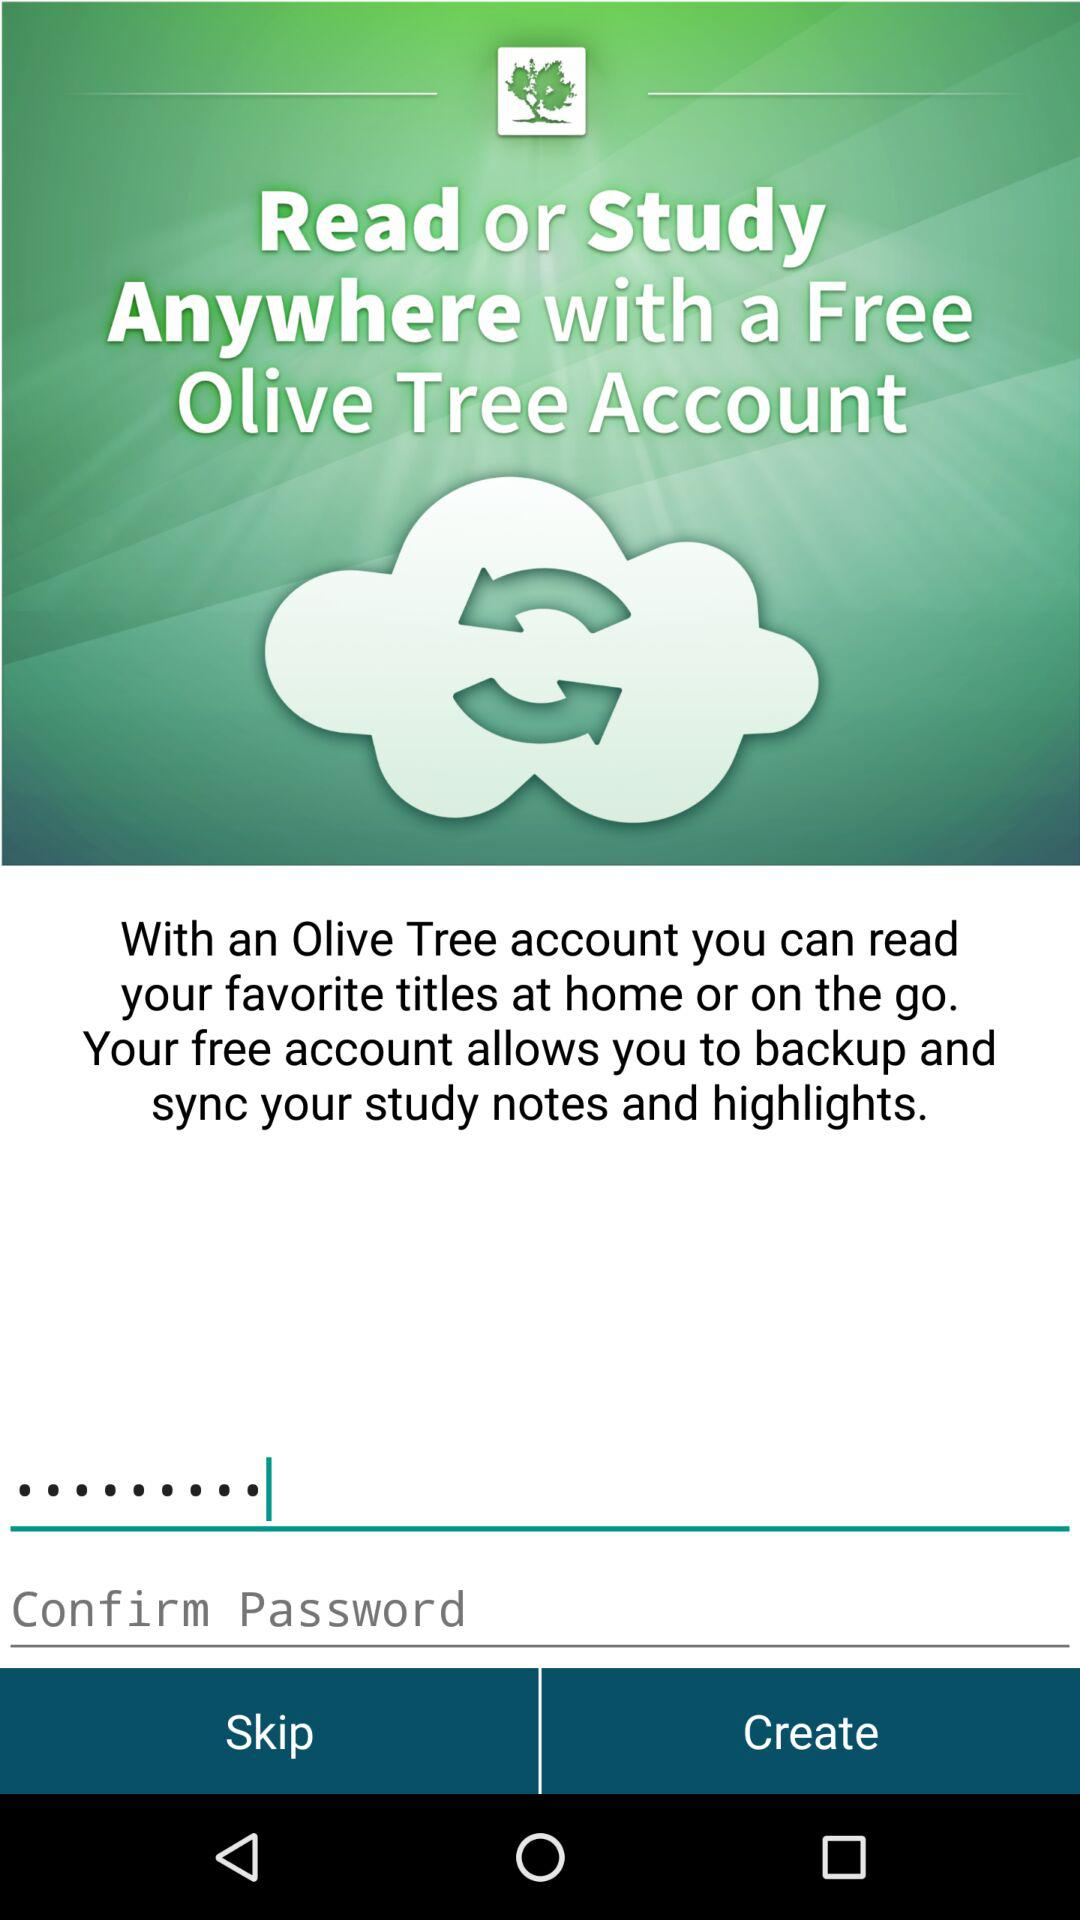How many text fields are there on the screen?
Answer the question using a single word or phrase. 2 